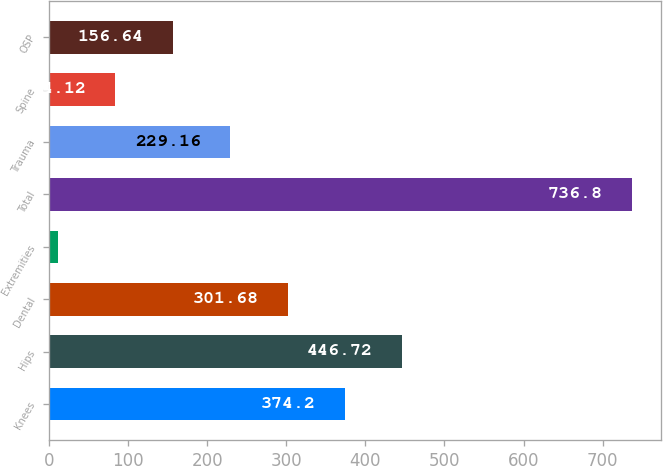<chart> <loc_0><loc_0><loc_500><loc_500><bar_chart><fcel>Knees<fcel>Hips<fcel>Dental<fcel>Extremities<fcel>Total<fcel>Trauma<fcel>Spine<fcel>OSP<nl><fcel>374.2<fcel>446.72<fcel>301.68<fcel>11.6<fcel>736.8<fcel>229.16<fcel>84.12<fcel>156.64<nl></chart> 